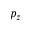<formula> <loc_0><loc_0><loc_500><loc_500>p _ { z }</formula> 